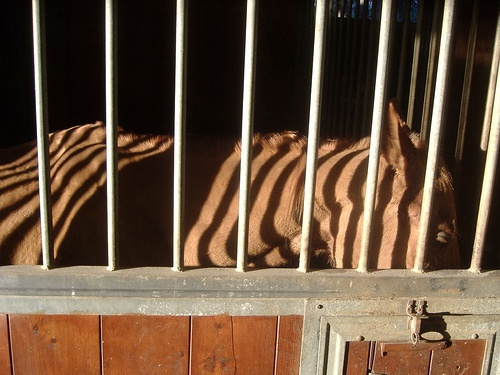Describe the objects in this image and their specific colors. I can see a horse in black, maroon, tan, and ivory tones in this image. 